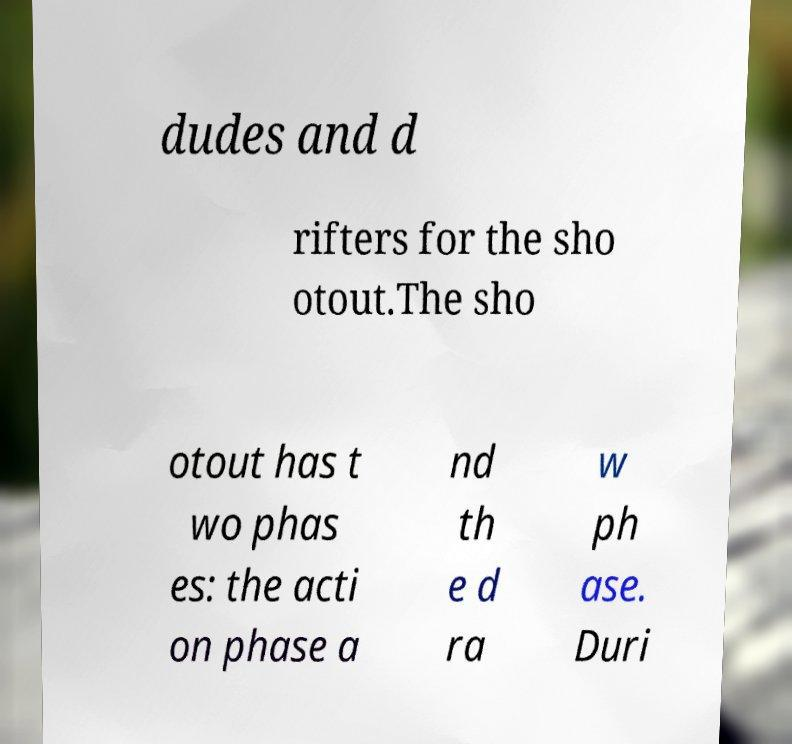There's text embedded in this image that I need extracted. Can you transcribe it verbatim? dudes and d rifters for the sho otout.The sho otout has t wo phas es: the acti on phase a nd th e d ra w ph ase. Duri 